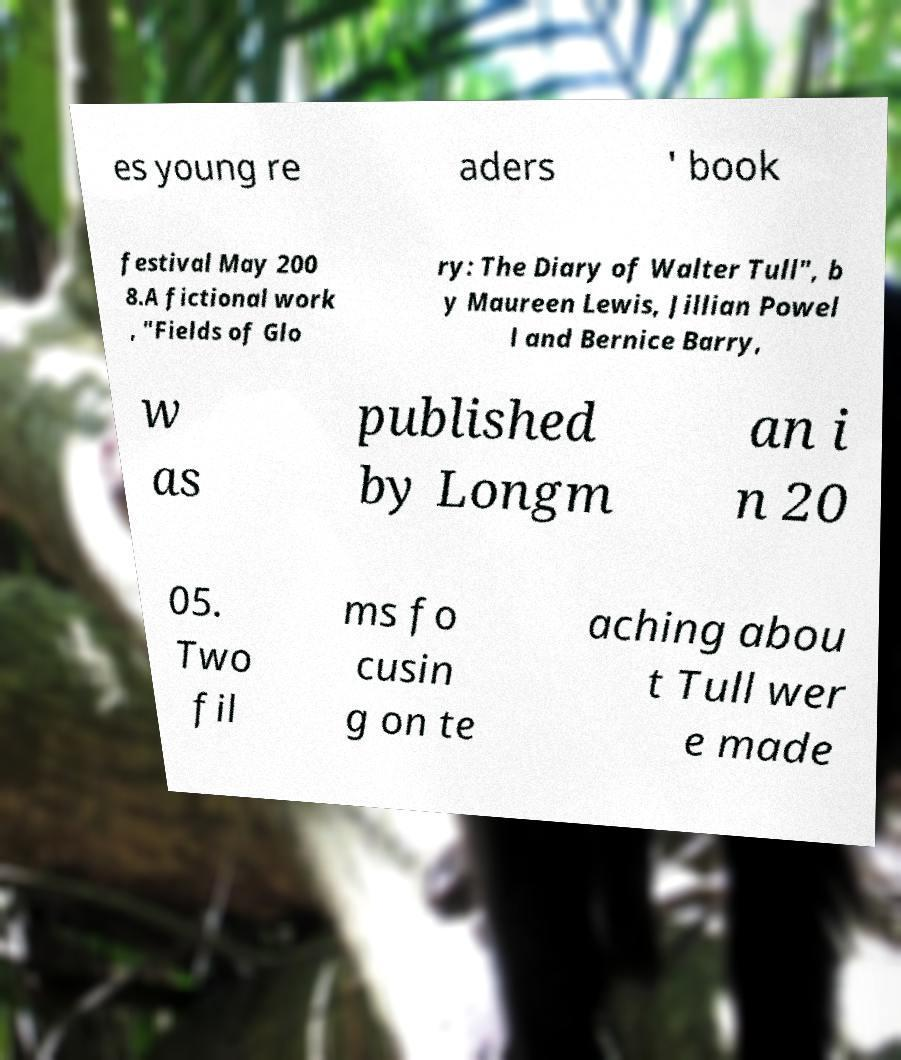Please identify and transcribe the text found in this image. es young re aders ' book festival May 200 8.A fictional work , "Fields of Glo ry: The Diary of Walter Tull", b y Maureen Lewis, Jillian Powel l and Bernice Barry, w as published by Longm an i n 20 05. Two fil ms fo cusin g on te aching abou t Tull wer e made 